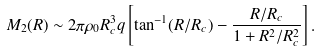Convert formula to latex. <formula><loc_0><loc_0><loc_500><loc_500>M _ { 2 } ( R ) \sim 2 \pi \rho _ { 0 } R _ { c } ^ { 3 } q \left [ \tan ^ { - 1 } ( R / R _ { c } ) - \frac { R / R _ { c } } { 1 + R ^ { 2 } / R _ { c } ^ { 2 } } \right ] .</formula> 